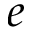<formula> <loc_0><loc_0><loc_500><loc_500>e</formula> 